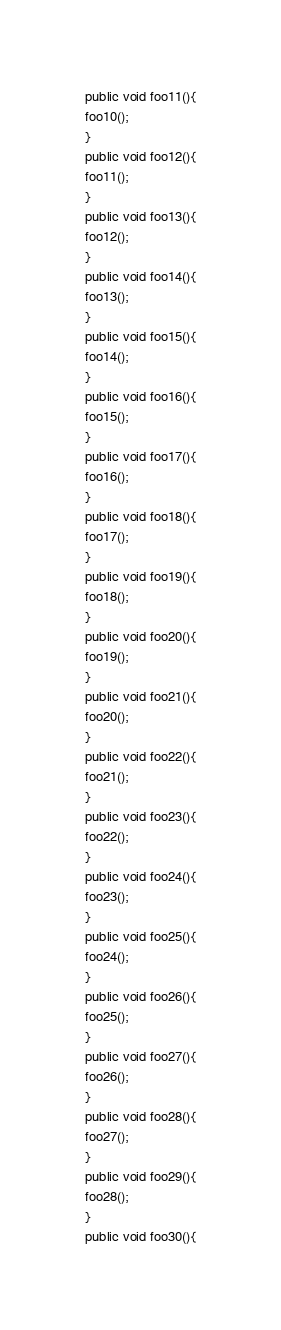<code> <loc_0><loc_0><loc_500><loc_500><_Java_>public void foo11(){
foo10();
}
public void foo12(){
foo11();
}
public void foo13(){
foo12();
}
public void foo14(){
foo13();
}
public void foo15(){
foo14();
}
public void foo16(){
foo15();
}
public void foo17(){
foo16();
}
public void foo18(){
foo17();
}
public void foo19(){
foo18();
}
public void foo20(){
foo19();
}
public void foo21(){
foo20();
}
public void foo22(){
foo21();
}
public void foo23(){
foo22();
}
public void foo24(){
foo23();
}
public void foo25(){
foo24();
}
public void foo26(){
foo25();
}
public void foo27(){
foo26();
}
public void foo28(){
foo27();
}
public void foo29(){
foo28();
}
public void foo30(){</code> 